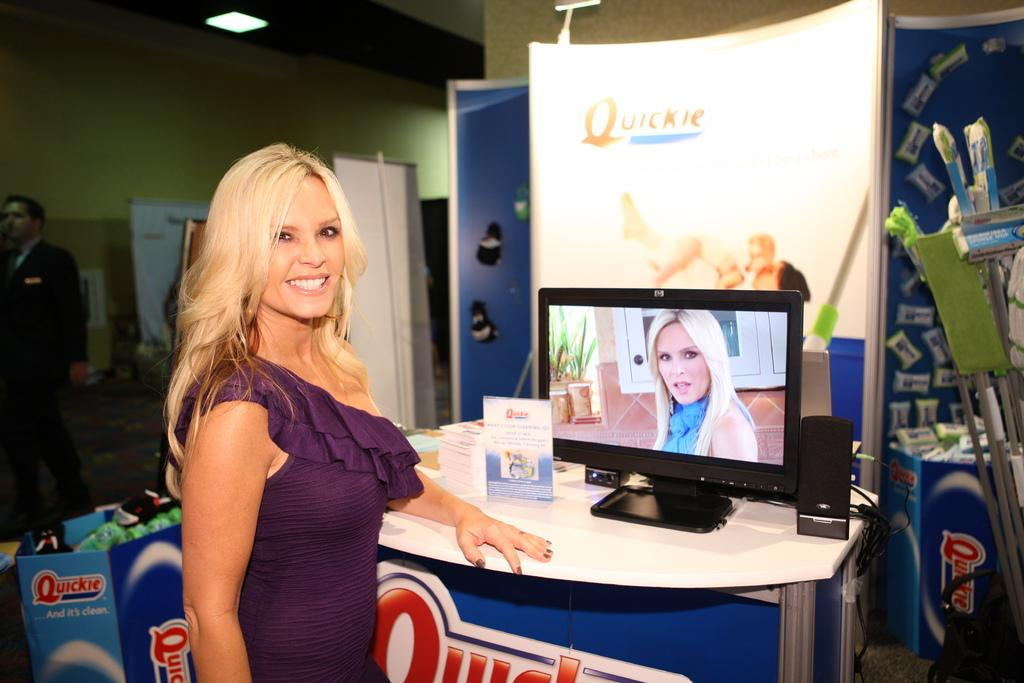Provide a one-sentence caption for the provided image. A woman stands in front of a display with a sign that says "quickie.". 